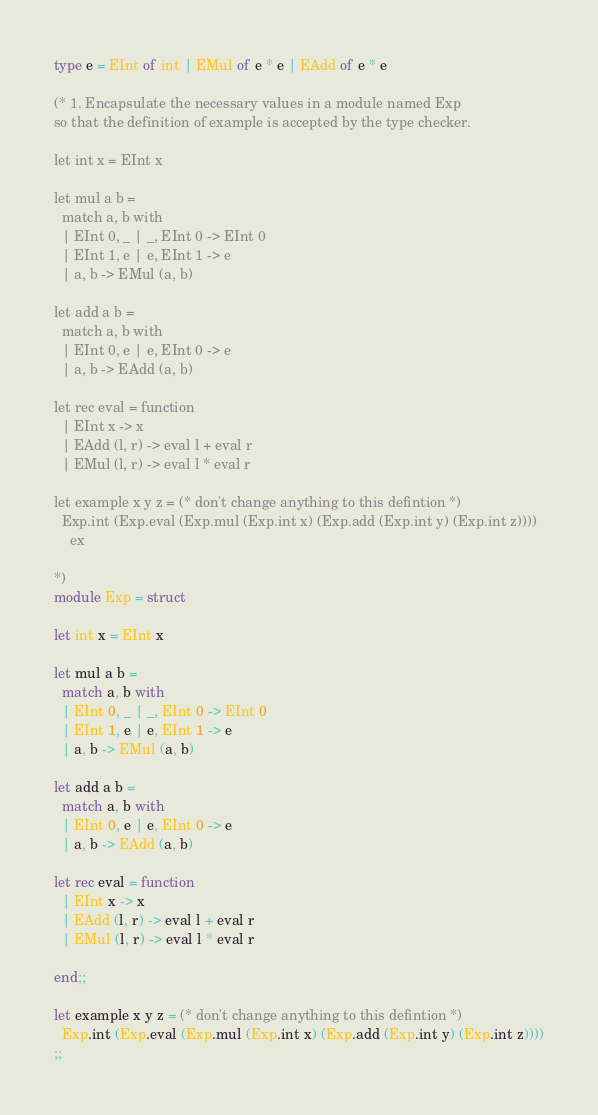Convert code to text. <code><loc_0><loc_0><loc_500><loc_500><_OCaml_>type e = EInt of int | EMul of e * e | EAdd of e * e

(* 1. Encapsulate the necessary values in a module named Exp
so that the definition of example is accepted by the type checker.

let int x = EInt x

let mul a b =
  match a, b with
  | EInt 0, _ | _, EInt 0 -> EInt 0
  | EInt 1, e | e, EInt 1 -> e
  | a, b -> EMul (a, b)

let add a b =
  match a, b with
  | EInt 0, e | e, EInt 0 -> e
  | a, b -> EAdd (a, b)

let rec eval = function
  | EInt x -> x
  | EAdd (l, r) -> eval l + eval r
  | EMul (l, r) -> eval l * eval r

let example x y z = (* don't change anything to this defintion *)
  Exp.int (Exp.eval (Exp.mul (Exp.int x) (Exp.add (Exp.int y) (Exp.int z))))
    ex

*)
module Exp = struct

let int x = EInt x

let mul a b =
  match a, b with
  | EInt 0, _ | _, EInt 0 -> EInt 0
  | EInt 1, e | e, EInt 1 -> e
  | a, b -> EMul (a, b)

let add a b =
  match a, b with
  | EInt 0, e | e, EInt 0 -> e
  | a, b -> EAdd (a, b)

let rec eval = function
  | EInt x -> x
  | EAdd (l, r) -> eval l + eval r
  | EMul (l, r) -> eval l * eval r

end;;

let example x y z = (* don't change anything to this defintion *)
  Exp.int (Exp.eval (Exp.mul (Exp.int x) (Exp.add (Exp.int y) (Exp.int z))))
;;</code> 